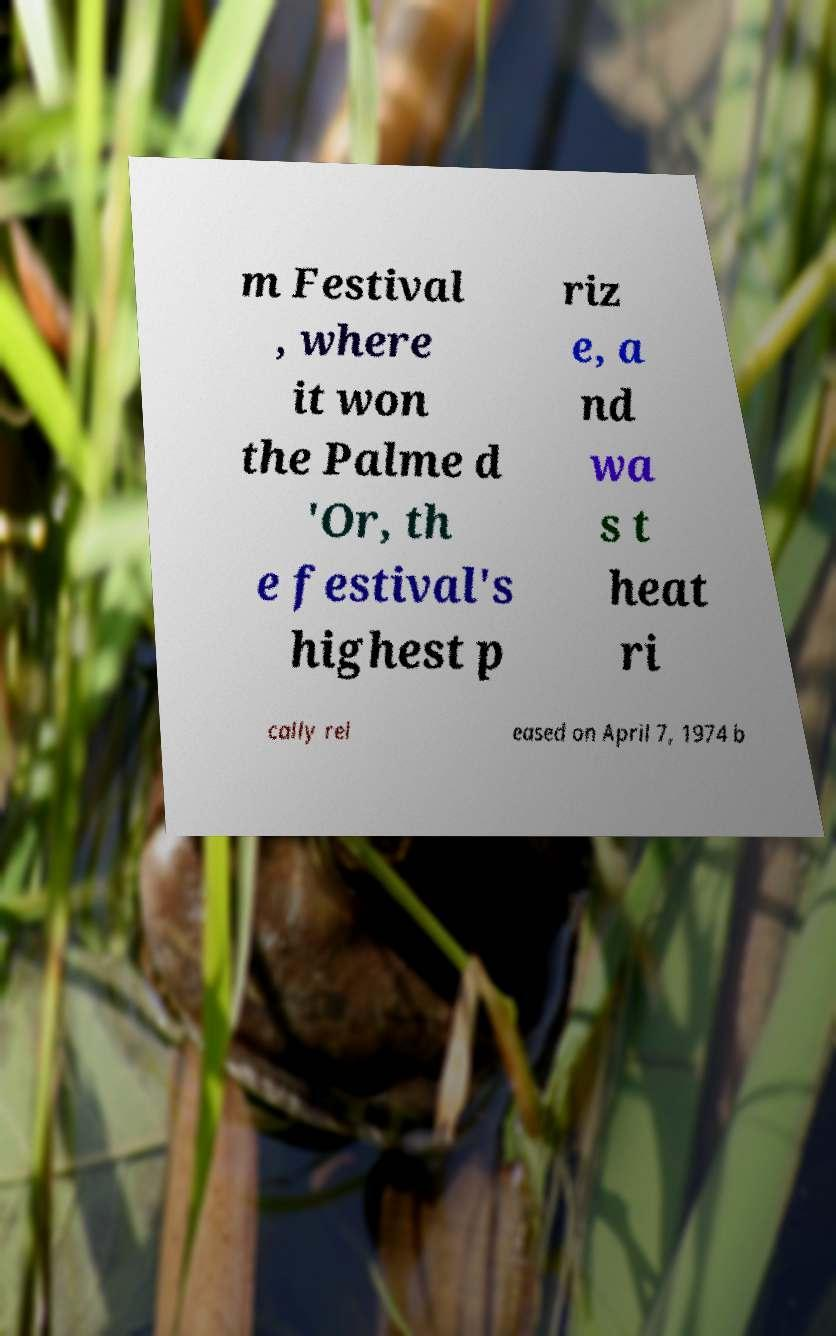There's text embedded in this image that I need extracted. Can you transcribe it verbatim? m Festival , where it won the Palme d 'Or, th e festival's highest p riz e, a nd wa s t heat ri cally rel eased on April 7, 1974 b 